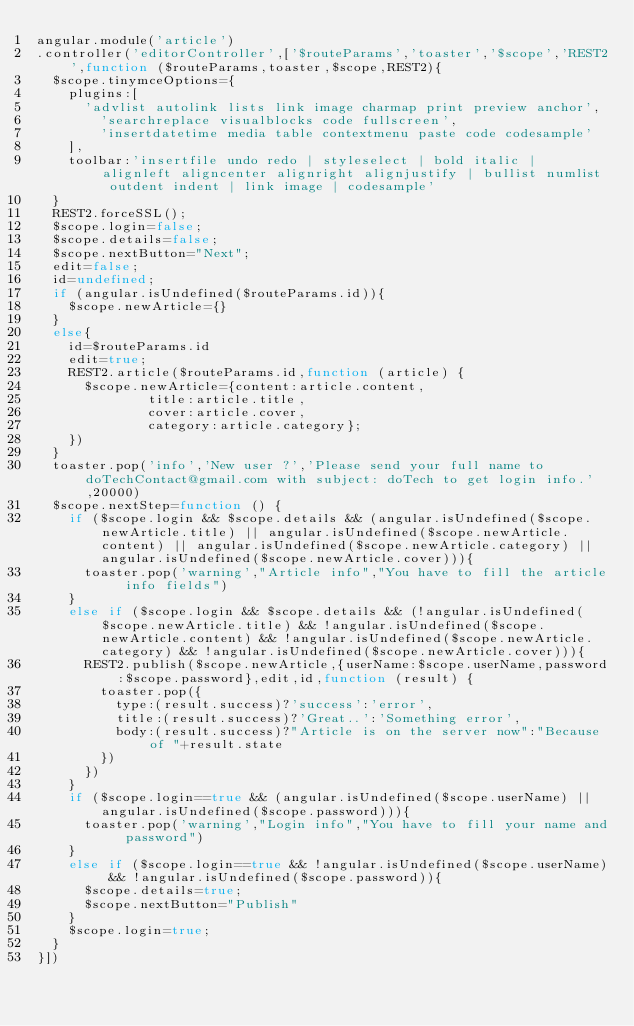Convert code to text. <code><loc_0><loc_0><loc_500><loc_500><_JavaScript_>angular.module('article')
.controller('editorController',['$routeParams','toaster','$scope','REST2',function ($routeParams,toaster,$scope,REST2){
	$scope.tinymceOptions={
		plugins:[
			'advlist autolink lists link image charmap print preview anchor',
    		'searchreplace visualblocks code fullscreen',
    		'insertdatetime media table contextmenu paste code codesample'
		],
		toolbar:'insertfile undo redo | styleselect | bold italic | alignleft aligncenter alignright alignjustify | bullist numlist outdent indent | link image | codesample'
	}
	REST2.forceSSL();
	$scope.login=false;
	$scope.details=false;
	$scope.nextButton="Next";
	edit=false;
	id=undefined;
	if (angular.isUndefined($routeParams.id)){
		$scope.newArticle={}
	}
	else{
		id=$routeParams.id
		edit=true;
		REST2.article($routeParams.id,function (article) {
			$scope.newArticle={content:article.content,
							title:article.title,
							cover:article.cover,
							category:article.category};
		})
	}
	toaster.pop('info','New user ?','Please send your full name to doTechContact@gmail.com with subject: doTech to get login info.',20000)
	$scope.nextStep=function () {
		if ($scope.login && $scope.details && (angular.isUndefined($scope.newArticle.title) || angular.isUndefined($scope.newArticle.content) || angular.isUndefined($scope.newArticle.category) || angular.isUndefined($scope.newArticle.cover))){
			toaster.pop('warning',"Article info","You have to fill the article info fields")
		}
		else if ($scope.login && $scope.details && (!angular.isUndefined($scope.newArticle.title) && !angular.isUndefined($scope.newArticle.content) && !angular.isUndefined($scope.newArticle.category) && !angular.isUndefined($scope.newArticle.cover))){
			REST2.publish($scope.newArticle,{userName:$scope.userName,password:$scope.password},edit,id,function (result) {
				toaster.pop({
					type:(result.success)?'success':'error',
					title:(result.success)?'Great..':'Something error',
					body:(result.success)?"Article is on the server now":"Because of "+result.state
				})
			})
		}
		if ($scope.login==true && (angular.isUndefined($scope.userName) || angular.isUndefined($scope.password))){
			toaster.pop('warning',"Login info","You have to fill your name and password")
		}
		else if ($scope.login==true && !angular.isUndefined($scope.userName) && !angular.isUndefined($scope.password)){
			$scope.details=true;
			$scope.nextButton="Publish"
		}
		$scope.login=true;
	}
}])
</code> 